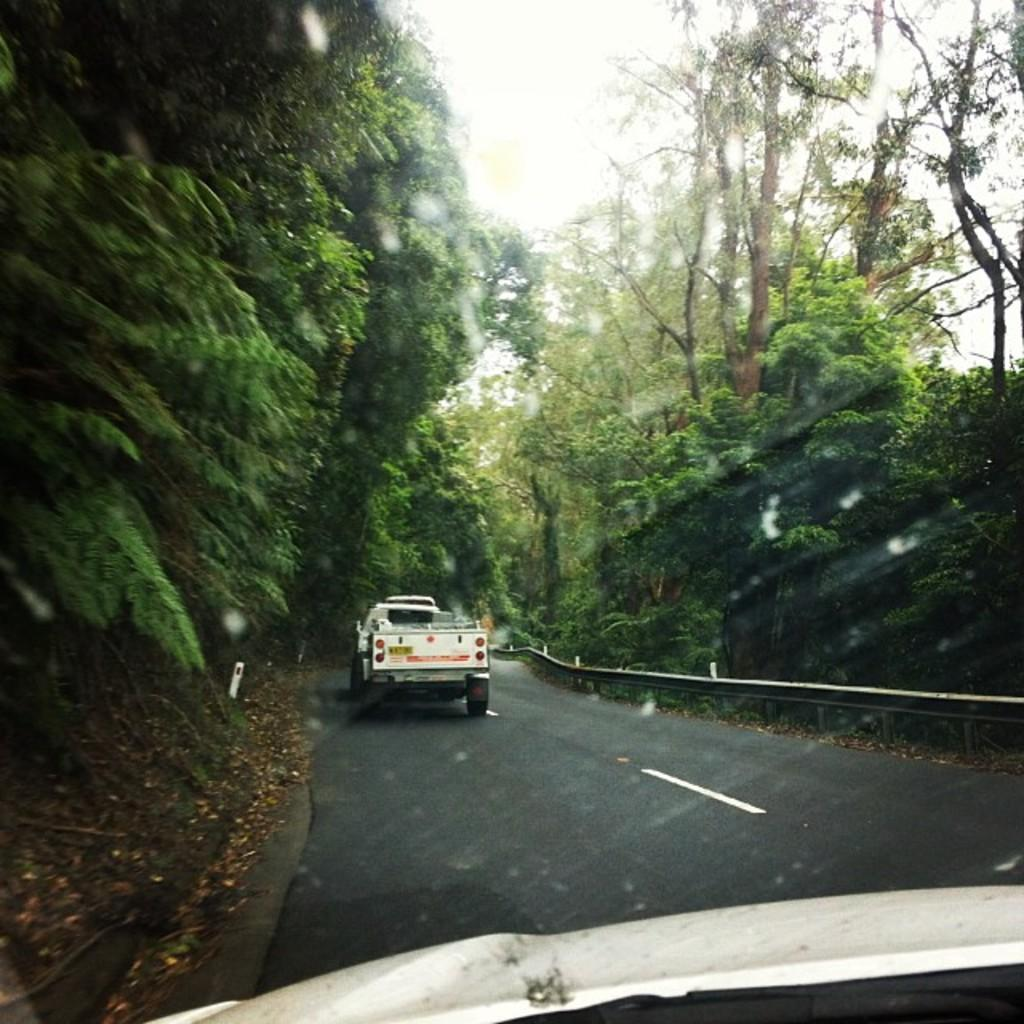What can be seen in the center of the image? There are vehicles on the road in the center of the image. What type of vegetation is on the right side of the image? There are trees on the right side of the image. What type of vegetation is on the left side of the image? There are trees on the left side of the image. What is visible in the background of the image? There is sky visible in the background of the image. What type of scent can be detected from the trees in the image? There is no information about the scent of the trees in the image, so it cannot be determined. Is there a trail visible in the image? There is no trail mentioned or visible in the image. 